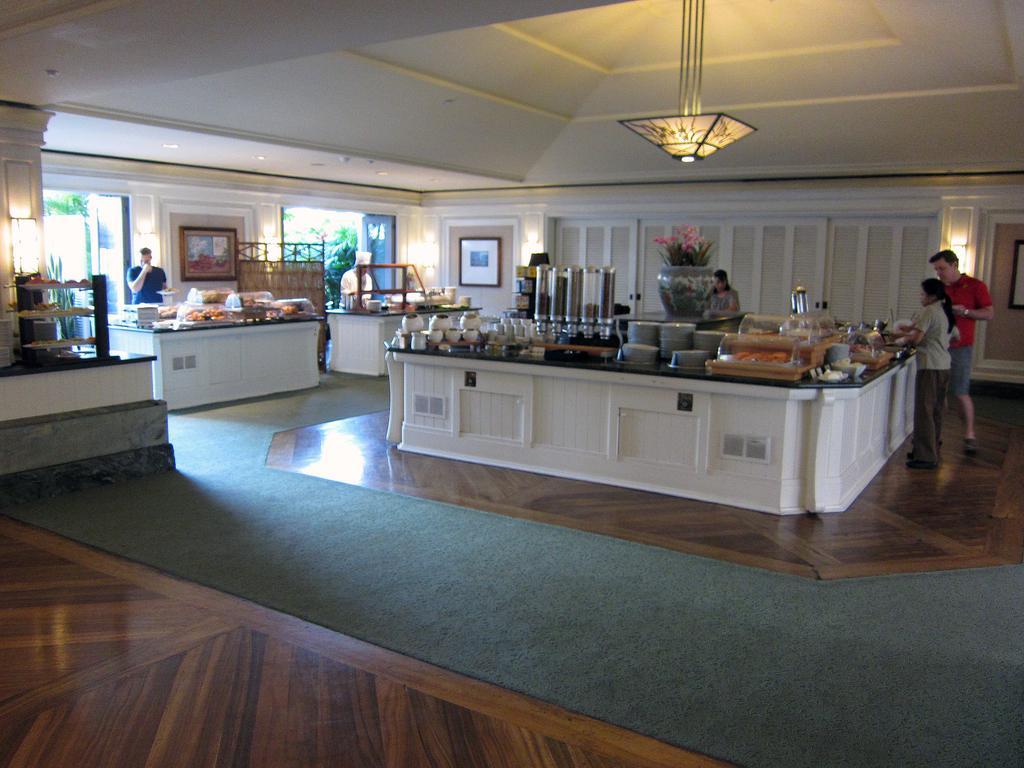Can you describe this image briefly? This image is clicked inside a kitchen, in the middle there is a table with bowls,vessels,plates,food on it and a flower vase in the middle of it, on the right side there are two persons standing in front of the table, in the middle there is a chandelier over the ceiling, on the left side there are two other tables with two persons standing behind it with food bowls on it. 